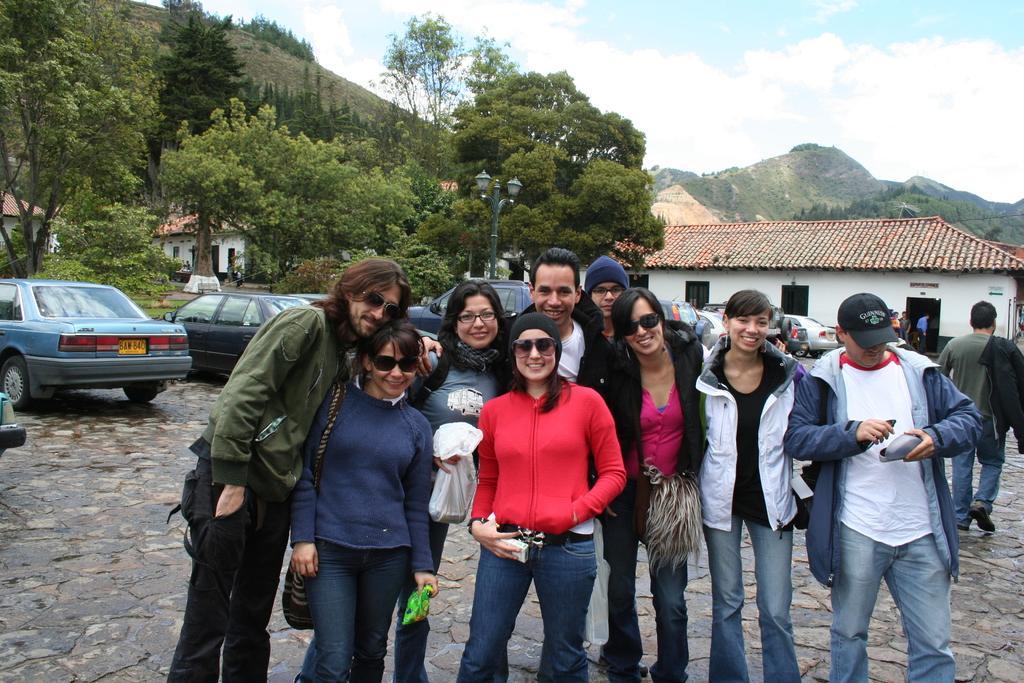In one or two sentences, can you explain what this image depicts? In this image there are clouds in the sky, there are mountains, there are trees, there are houses, there are cars, there are a group of people standing and holding an object, there is a person walking on the right of the image. 